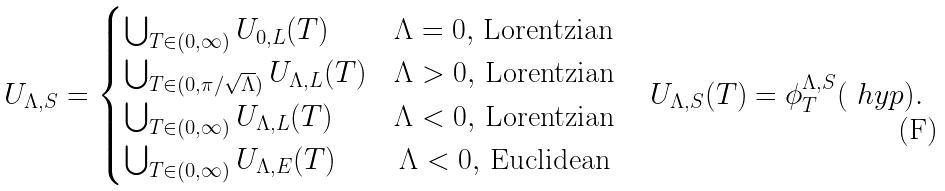<formula> <loc_0><loc_0><loc_500><loc_500>& U _ { \Lambda , S } = \begin{cases} \bigcup _ { T \in ( 0 , \infty ) } U _ { 0 , L } ( T ) & \Lambda = 0 , \, \text {Lorentzian} \\ \bigcup _ { T \in ( 0 , \pi / \sqrt { \Lambda } ) } U _ { \Lambda , L } ( T ) & \Lambda > 0 , \, \text {Lorentzian} \\ \bigcup _ { T \in ( 0 , \infty ) } U _ { \Lambda , L } ( T ) & \Lambda < 0 , \, \text {Lorentzian} \\ \bigcup _ { T \in ( 0 , \infty ) } U _ { \Lambda , E } ( T ) & \, \Lambda < 0 , \, \text {Euclidean} \end{cases} \quad U _ { \Lambda , S } ( T ) = \phi _ { T } ^ { \Lambda , S } ( \ h y p ) .</formula> 